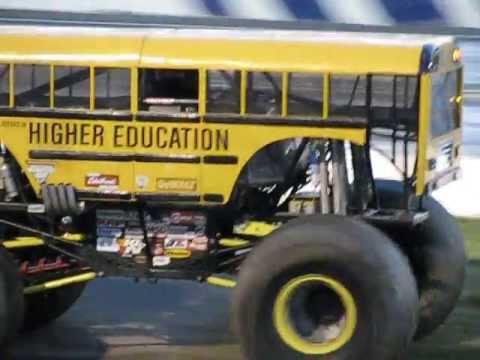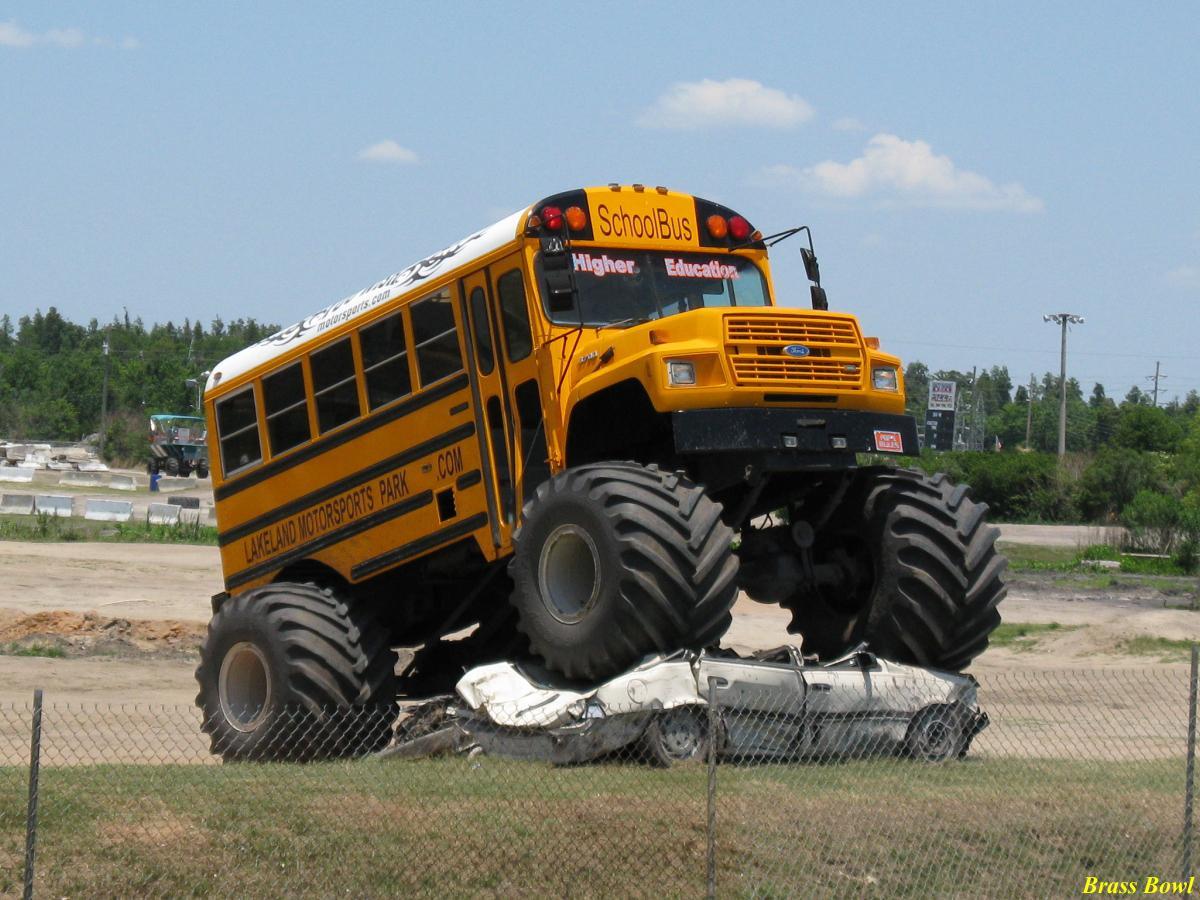The first image is the image on the left, the second image is the image on the right. Considering the images on both sides, is "In the left image a monster bus is driving over another vehicle." valid? Answer yes or no. No. The first image is the image on the left, the second image is the image on the right. Evaluate the accuracy of this statement regarding the images: "One image shows a big-wheeled yellow school bus with its front tires on top of a squashed white car.". Is it true? Answer yes or no. Yes. 